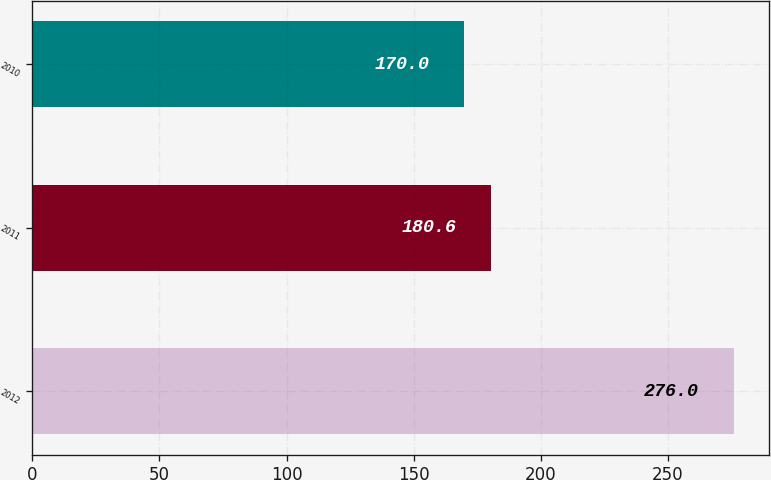Convert chart to OTSL. <chart><loc_0><loc_0><loc_500><loc_500><bar_chart><fcel>2012<fcel>2011<fcel>2010<nl><fcel>276<fcel>180.6<fcel>170<nl></chart> 